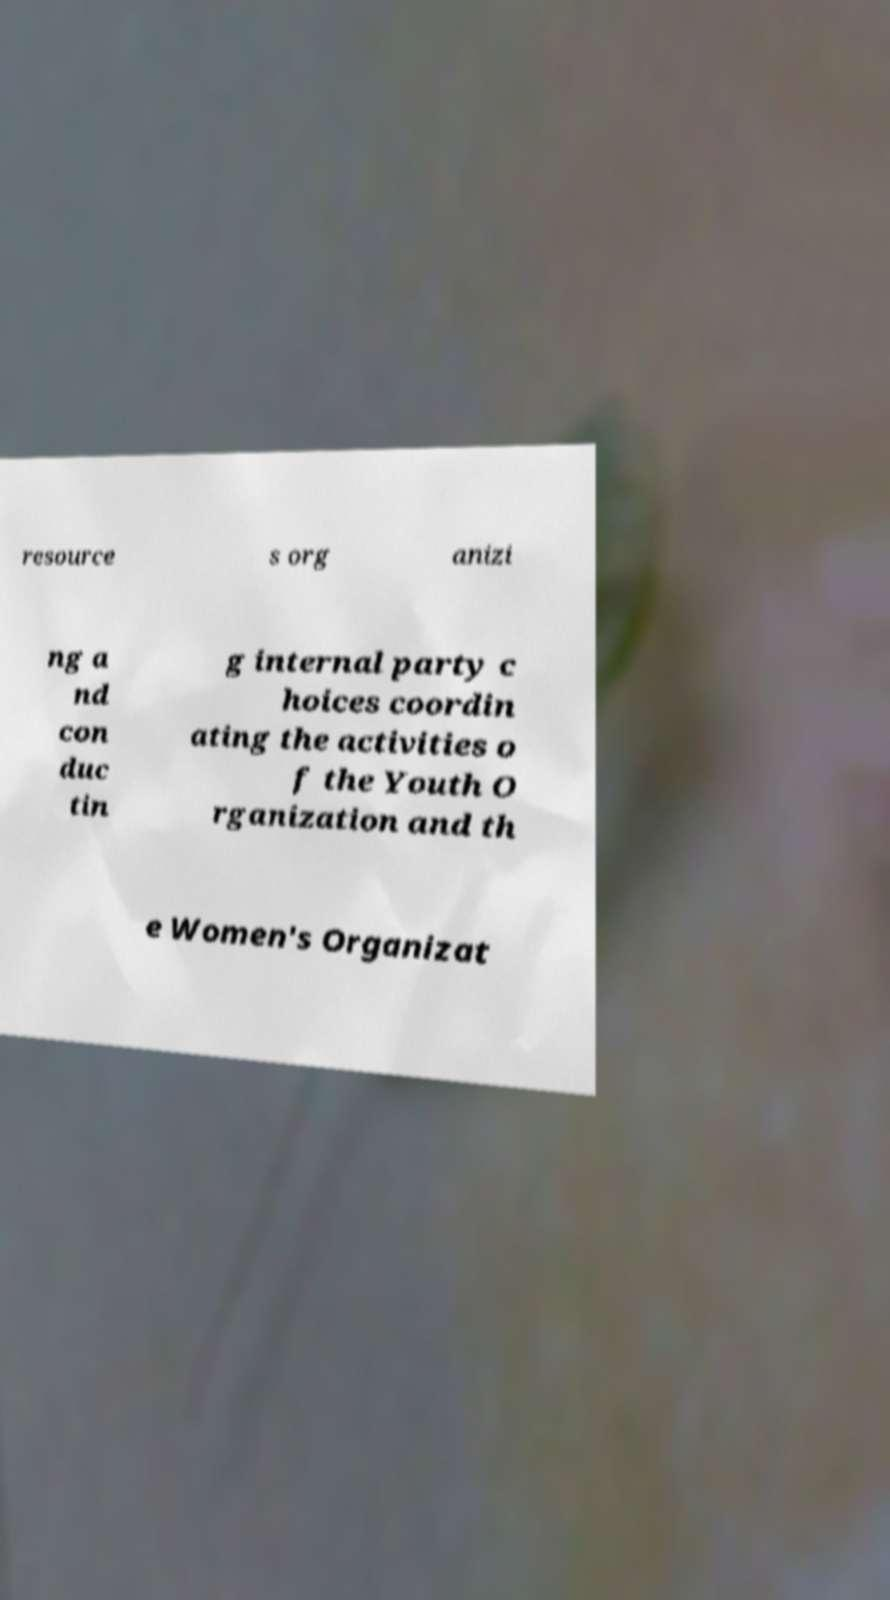There's text embedded in this image that I need extracted. Can you transcribe it verbatim? resource s org anizi ng a nd con duc tin g internal party c hoices coordin ating the activities o f the Youth O rganization and th e Women's Organizat 